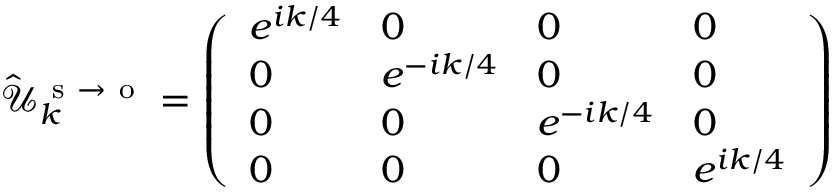<formula> <loc_0><loc_0><loc_500><loc_500>\hat { \mathcal { U } } _ { k } ^ { s \to o } = \left ( \begin{array} { l l l l } { e ^ { i k / 4 } } & { 0 } & { 0 } & { 0 } \\ { 0 } & { e ^ { - i k / 4 } } & { 0 } & { 0 } \\ { 0 } & { 0 } & { e ^ { - i k / 4 } } & { 0 } \\ { 0 } & { 0 } & { 0 } & { e ^ { i k / 4 } } \end{array} \right )</formula> 